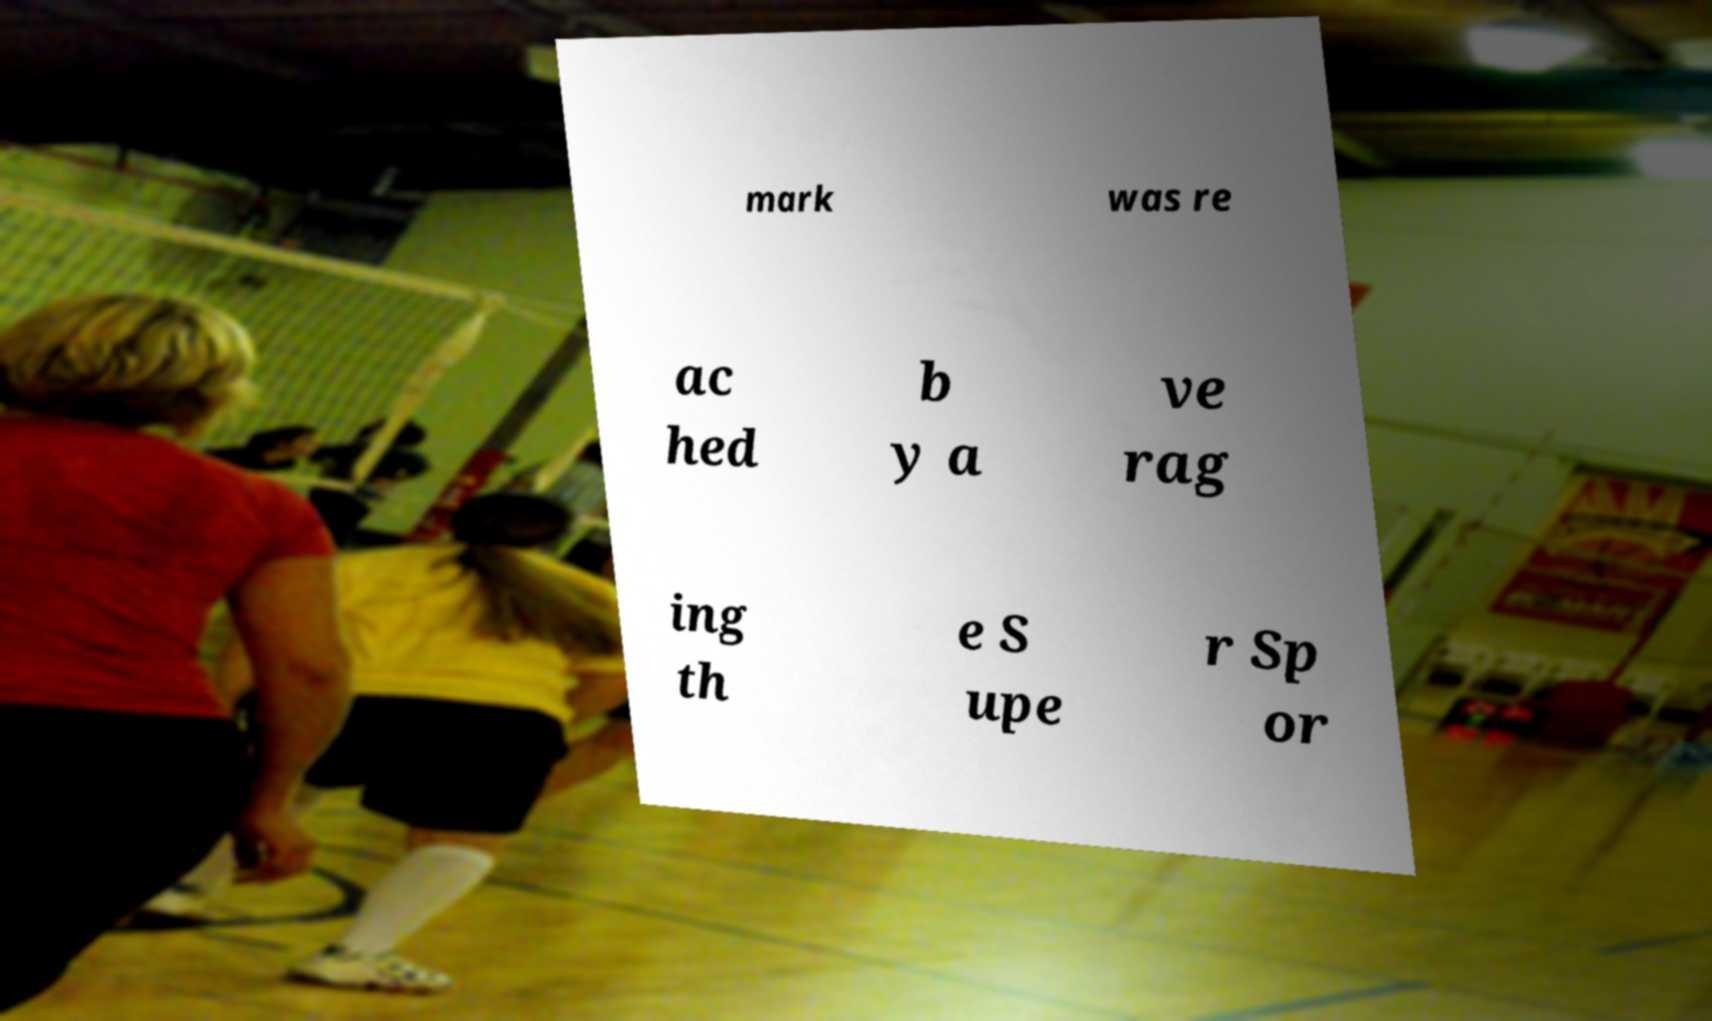I need the written content from this picture converted into text. Can you do that? mark was re ac hed b y a ve rag ing th e S upe r Sp or 